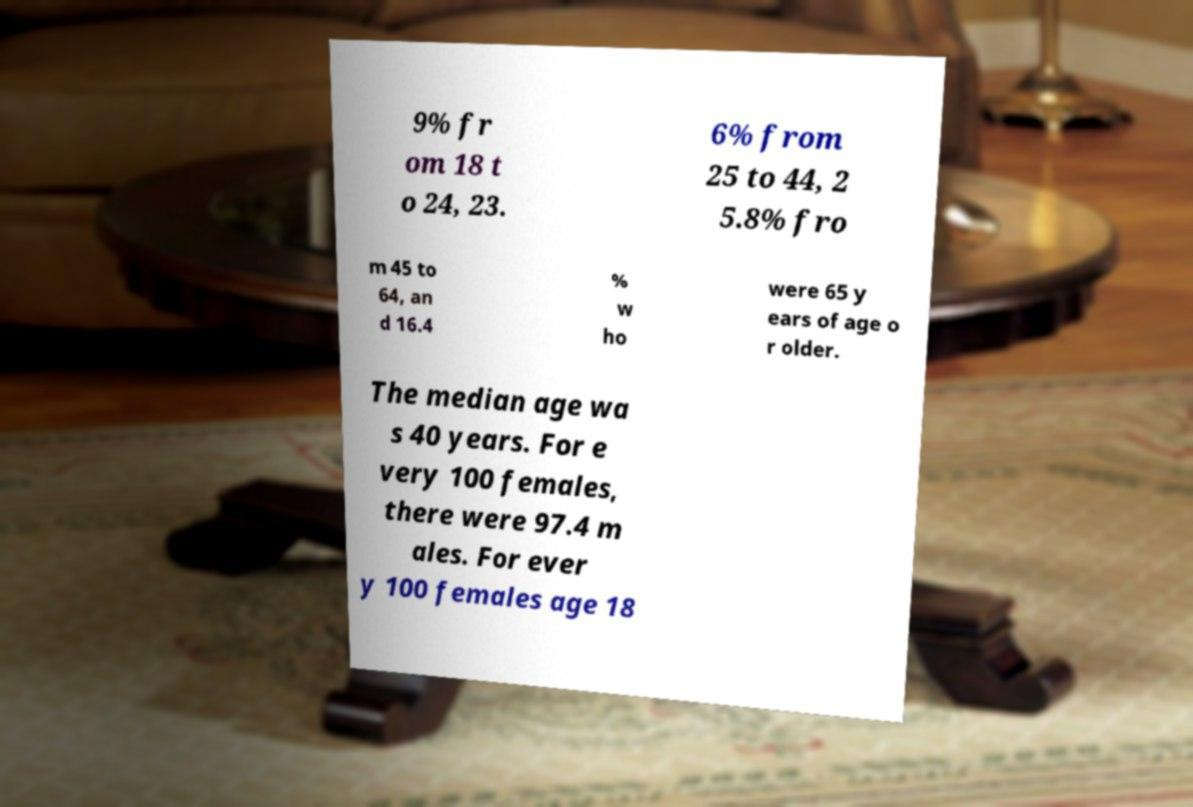There's text embedded in this image that I need extracted. Can you transcribe it verbatim? 9% fr om 18 t o 24, 23. 6% from 25 to 44, 2 5.8% fro m 45 to 64, an d 16.4 % w ho were 65 y ears of age o r older. The median age wa s 40 years. For e very 100 females, there were 97.4 m ales. For ever y 100 females age 18 